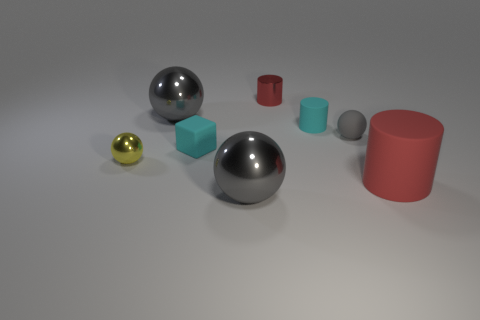How many gray spheres must be subtracted to get 1 gray spheres? 2 Add 1 big gray matte cylinders. How many objects exist? 9 Subtract all big rubber cylinders. How many cylinders are left? 2 Subtract all cylinders. How many objects are left? 5 Subtract 3 cylinders. How many cylinders are left? 0 Subtract all purple cubes. Subtract all yellow spheres. How many cubes are left? 1 Subtract all red balls. How many cyan cylinders are left? 1 Subtract all cyan matte cylinders. Subtract all small cyan things. How many objects are left? 5 Add 7 small red metal cylinders. How many small red metal cylinders are left? 8 Add 2 small cyan cubes. How many small cyan cubes exist? 3 